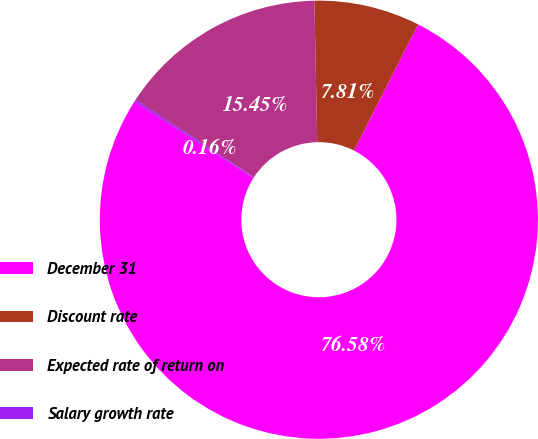<chart> <loc_0><loc_0><loc_500><loc_500><pie_chart><fcel>December 31<fcel>Discount rate<fcel>Expected rate of return on<fcel>Salary growth rate<nl><fcel>76.58%<fcel>7.81%<fcel>15.45%<fcel>0.16%<nl></chart> 